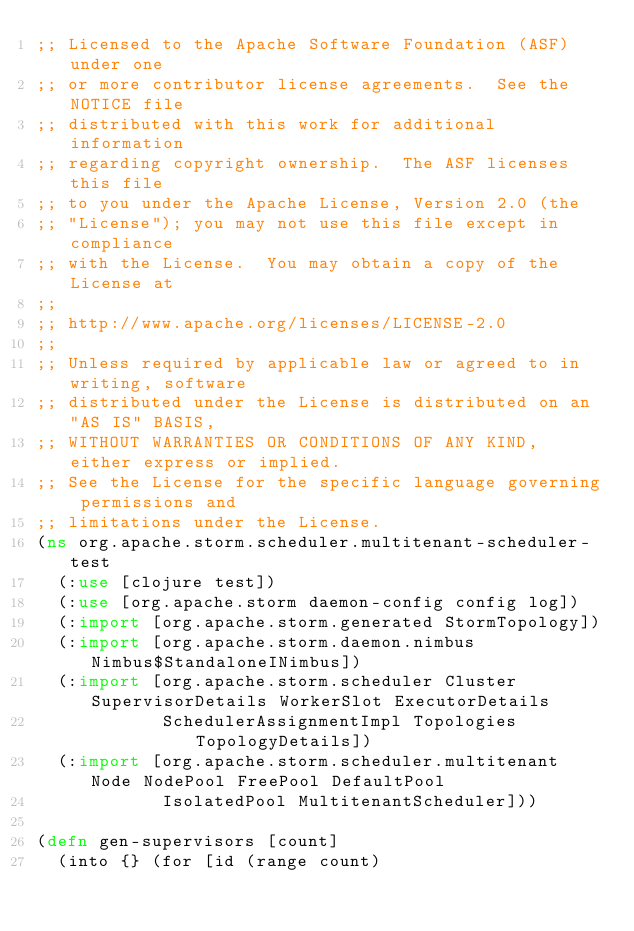<code> <loc_0><loc_0><loc_500><loc_500><_Clojure_>;; Licensed to the Apache Software Foundation (ASF) under one
;; or more contributor license agreements.  See the NOTICE file
;; distributed with this work for additional information
;; regarding copyright ownership.  The ASF licenses this file
;; to you under the Apache License, Version 2.0 (the
;; "License"); you may not use this file except in compliance
;; with the License.  You may obtain a copy of the License at
;;
;; http://www.apache.org/licenses/LICENSE-2.0
;;
;; Unless required by applicable law or agreed to in writing, software
;; distributed under the License is distributed on an "AS IS" BASIS,
;; WITHOUT WARRANTIES OR CONDITIONS OF ANY KIND, either express or implied.
;; See the License for the specific language governing permissions and
;; limitations under the License.
(ns org.apache.storm.scheduler.multitenant-scheduler-test
  (:use [clojure test])
  (:use [org.apache.storm daemon-config config log])
  (:import [org.apache.storm.generated StormTopology])
  (:import [org.apache.storm.daemon.nimbus Nimbus$StandaloneINimbus])
  (:import [org.apache.storm.scheduler Cluster SupervisorDetails WorkerSlot ExecutorDetails
            SchedulerAssignmentImpl Topologies TopologyDetails])
  (:import [org.apache.storm.scheduler.multitenant Node NodePool FreePool DefaultPool
            IsolatedPool MultitenantScheduler]))

(defn gen-supervisors [count]
  (into {} (for [id (range count)</code> 